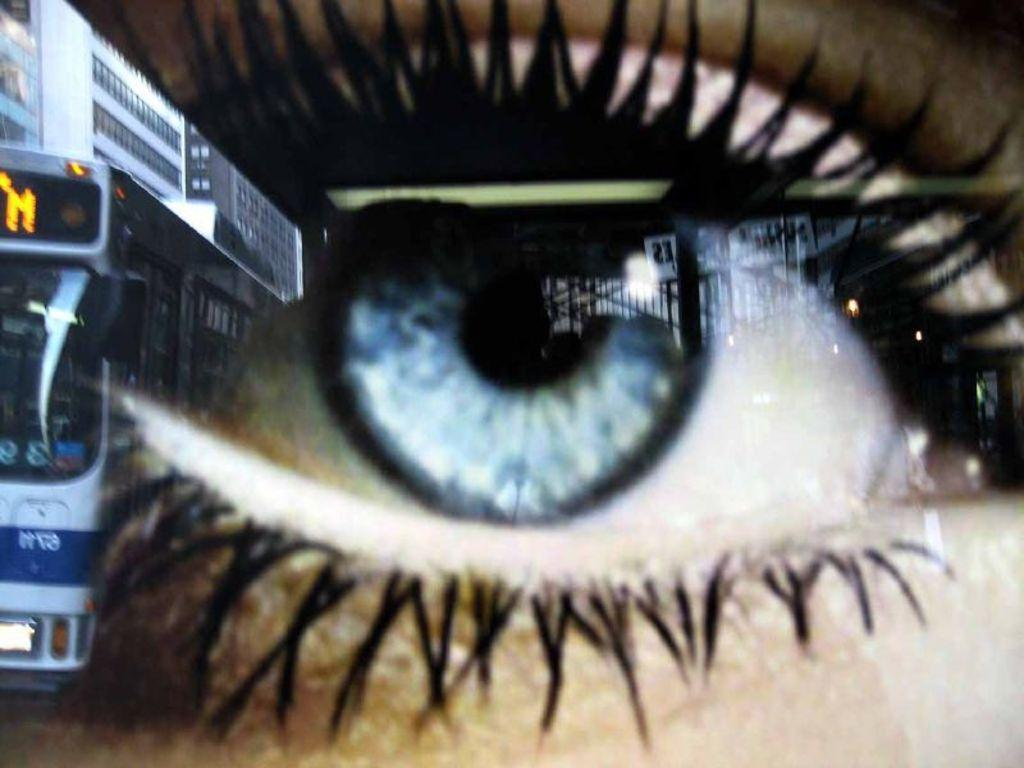What is the main subject of the image? The main subject of the image is a picture of an eye. What can be seen on the left side of the image? There is a bus on the left side of the image. What type of structures are visible in the image? There are buildings visible in the image. What type of lamp is hanging from the eye in the image? There is no lamp present in the image, as it features a picture of an eye and a bus on the left side. 